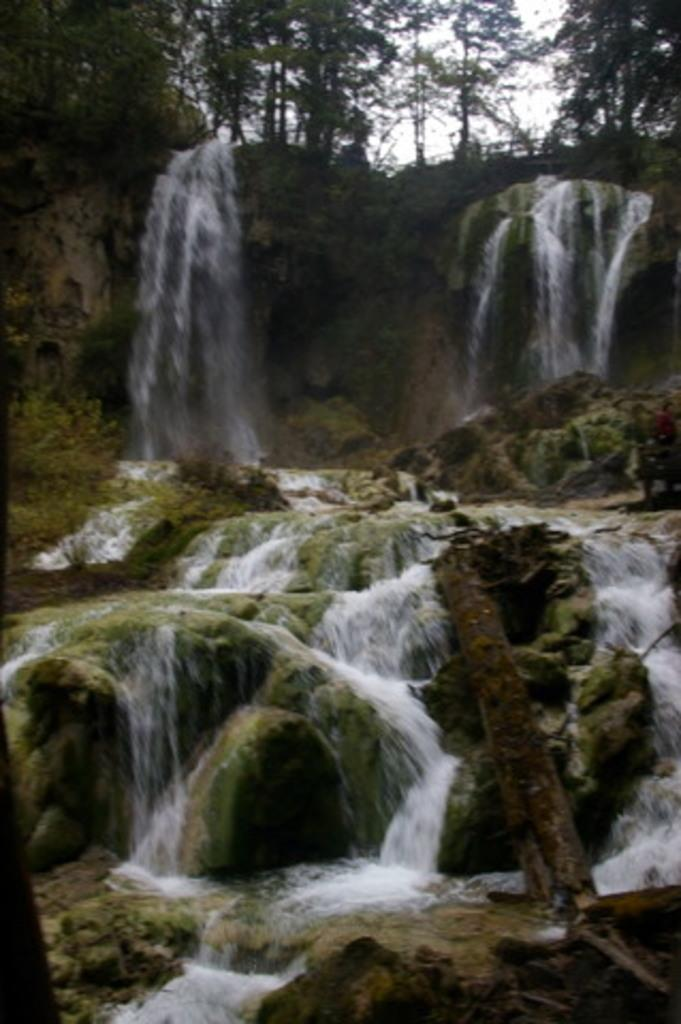What type of environment is depicted in the image? The image is an outside view. What natural features can be seen in the image? There are waterfalls in the image. What object is located on the right side of the image? There is a trunk on the right side of the image. What type of vegetation is visible at the top of the image? There are trees at the top of the image. What type of bed can be seen in the image? There is no bed present in the image; it is an outside view with waterfalls, a trunk, and trees. What type of worm is crawling on the trunk in the image? There are no worms visible in the image; it only shows waterfalls, a trunk, and trees. 